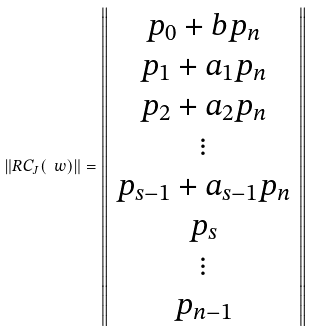<formula> <loc_0><loc_0><loc_500><loc_500>\left \| R C _ { J } ( \ w ) \right \| = \left \| \begin{array} { c } p _ { 0 } + b p _ { n } \\ p _ { 1 } + a _ { 1 } p _ { n } \\ p _ { 2 } + a _ { 2 } p _ { n } \\ \vdots \\ p _ { s - 1 } + a _ { s - 1 } p _ { n } \\ p _ { s } \\ \vdots \\ p _ { n - 1 } \\ \end{array} \right \|</formula> 